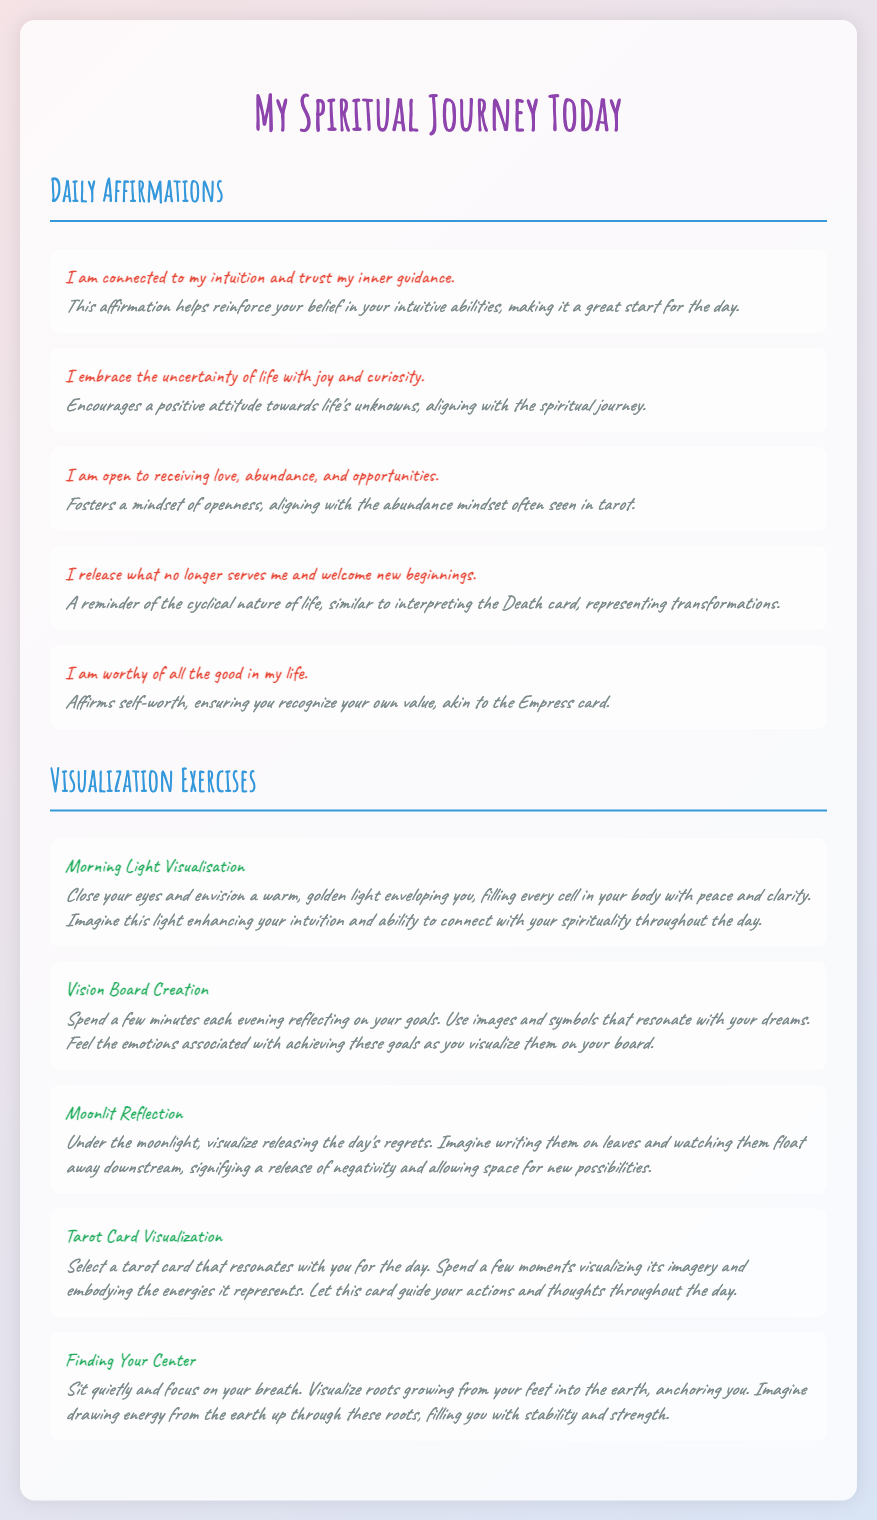what is the title of the document? The title of the document is displayed prominently at the top, indicating the content is related to a spiritual journey.
Answer: My Spiritual Journey Today how many daily affirmations are listed? The document includes a section for daily affirmations that lists a total of five affirmations.
Answer: 5 what is the first affirmation? The first affirmation is the statement designed to enhance one's belief in their intuition and guidance.
Answer: I am connected to my intuition and trust my inner guidance what visualization exercise involves the moonlight? This visualization exercise is about releasing negativity and is specifically linked to the moonlit theme.
Answer: Moonlit Reflection which affirmation encourages a positive attitude towards life's unknowns? This affirmation cultivates a mindset open to the uncertainties of life, essential for spiritual growth.
Answer: I embrace the uncertainty of life with joy and curiosity how many visualization exercises are there? The visualization exercises section contains a total of five exercises that can enhance spiritual practice.
Answer: 5 which exercise focuses on grounding and stability? This visualization exercise aims to help individuals find their center and feel rooted and stable.
Answer: Finding Your Center what concept does the affirmation about self-worth relate to in tarot? This affirmation connects the idea of recognizing one's value to a specific archetype present in tarot.
Answer: Empress card which exercise involves creating a visual representation of goals? This exercise encourages individuals to engage creatively with their aspirations.
Answer: Vision Board Creation 